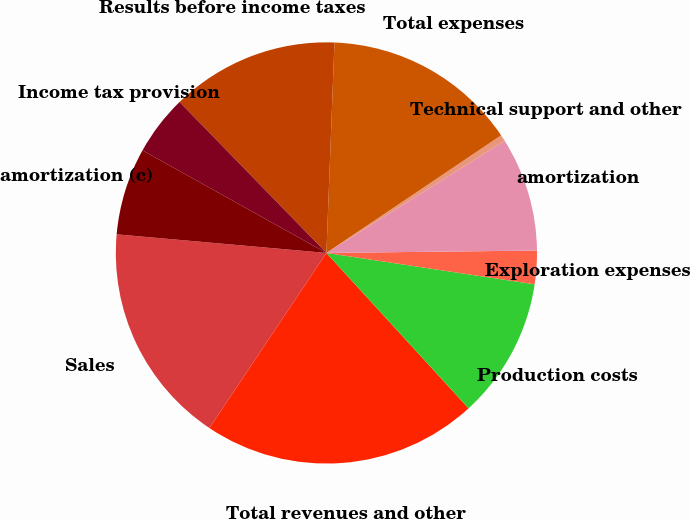<chart> <loc_0><loc_0><loc_500><loc_500><pie_chart><fcel>Sales<fcel>Total revenues and other<fcel>Production costs<fcel>Exploration expenses<fcel>amortization<fcel>Technical support and other<fcel>Total expenses<fcel>Results before income taxes<fcel>Income tax provision<fcel>amortization (c)<nl><fcel>17.03%<fcel>21.17%<fcel>10.83%<fcel>2.56%<fcel>8.76%<fcel>0.49%<fcel>14.96%<fcel>12.89%<fcel>4.62%<fcel>6.69%<nl></chart> 